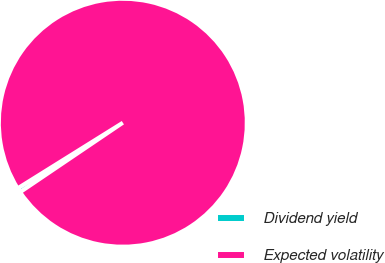Convert chart to OTSL. <chart><loc_0><loc_0><loc_500><loc_500><pie_chart><fcel>Dividend yield<fcel>Expected volatility<nl><fcel>0.59%<fcel>99.41%<nl></chart> 